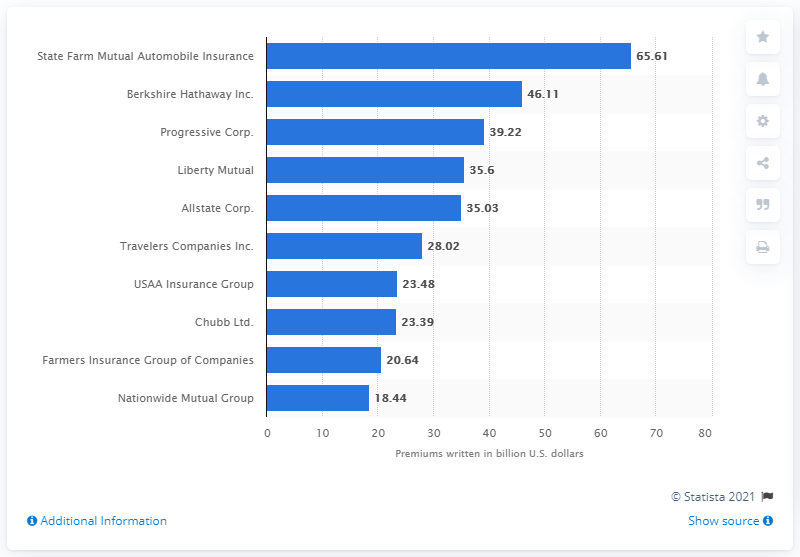Draw attention to some important aspects in this diagram. The value for Allstate Corp is 35.03. In 2019, Liberty Mutual wrote $35.6 billion in direct property and casualty premiums. The total value of the top and bottom bars in the chart is 84.05. In 2019, Liberty Mutual wrote the most direct property/casualty premiums among all insurance companies. 